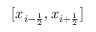<formula> <loc_0><loc_0><loc_500><loc_500>[ x _ { i - \frac { 1 } { 2 } } , x _ { i + \frac { 1 } { 2 } } ]</formula> 